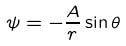Convert formula to latex. <formula><loc_0><loc_0><loc_500><loc_500>\psi = - \frac { A } { r } \sin \theta</formula> 